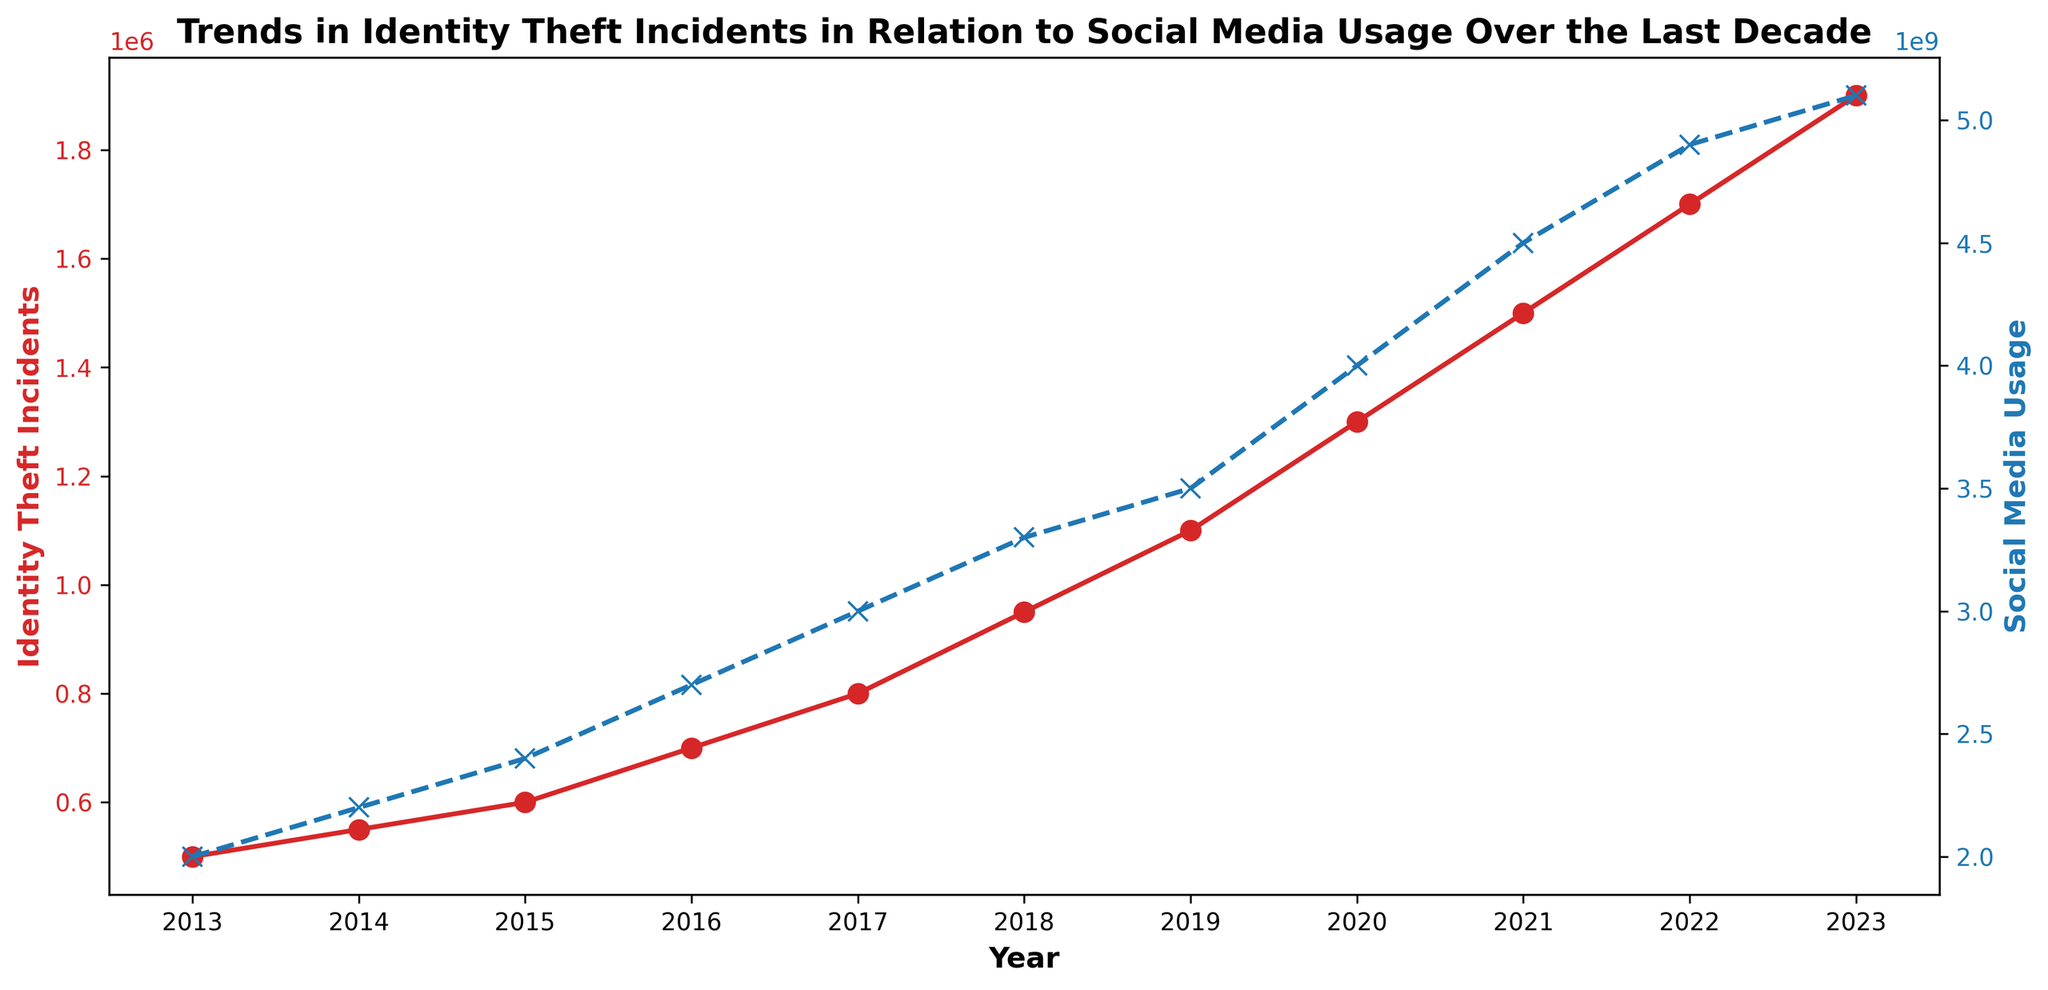How has the trend in identity theft incidents changed over the decade? The red line representing identity theft incidents shows a consistent upward trend from 2013 to 2023. The incidents started at 500,000 in 2013 and rose to 1,900,000 in 2023.
Answer: Increasing consistently What year saw the highest increase in identity theft incidents? By examining the steepest upward slope in the red line, between 2022 and 2023, the increase is from 1,700,000 to 1,900,000, which is the highest increment of 200,000.
Answer: 2023 Compare social media usage between 2013 and 2023. How much has it increased? In 2013, social media usage was 2,000,000,000 and it increased to 5,100,000,000 in 2023. The difference is 5,100,000,000 - 2,000,000,000 = 3,100,000,000.
Answer: 3,100,000,000 Is there any year in which identity theft incidents remained constant or decreased compared to the previous year? By following the red line, it is evident that there is no year with constant or decreasing incidents; the trend is consistently increasing.
Answer: No How does the trend in social media usage relate to the trend in identity theft incidents? Both trends show an upward movement. As the blue dashed line for social media usage increases, the red line for identity theft incidents also rises. This suggests a possible correlation between the two.
Answer: Both trends increase Which year had the closest number of identity theft incidents and social media usage? This is a trick question as the orders of magnitude are different; no year has close values. Social media usage is in billions, while identity theft incidents are in millions.
Answer: None What is the total number of identity theft incidents over the decade shown? Sum all the identity theft incidents: 500,000 + 550,000 + 600,000 + 700,000 + 800,000 + 950,000 + 1,100,000 + 1,300,000 + 1,500,000 + 1,700,000 + 1,900,000 = 11,600,000.
Answer: 11,600,000 Between which consecutive years did social media usage increase the most? By inspecting the blue dashed line, look for the steepest slope. The highest increase is between 2019 (3,500,000,000) and 2020 (4,000,000,000) with an increase of 500,000,000.
Answer: 2019-2020 What is the average annual increase in identity theft incidents over the decade? To find the average increase: (1,900,000 - 500,000) / 10 = 1,400,000 / 10 = 140,000.
Answer: 140,000 